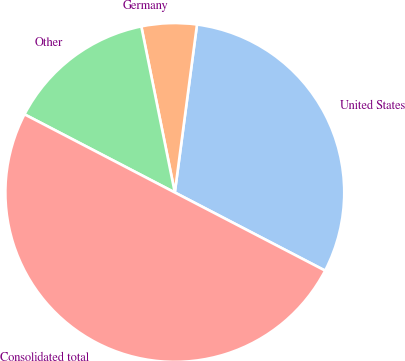Convert chart to OTSL. <chart><loc_0><loc_0><loc_500><loc_500><pie_chart><fcel>United States<fcel>Germany<fcel>Other<fcel>Consolidated total<nl><fcel>30.54%<fcel>5.26%<fcel>14.2%<fcel>50.0%<nl></chart> 